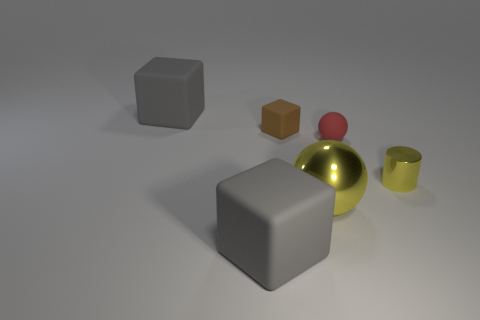What is the material of the large yellow ball?
Your answer should be compact. Metal. What number of metallic objects are tiny gray cylinders or large gray cubes?
Your answer should be very brief. 0. Is the number of small yellow cylinders that are left of the big yellow ball less than the number of gray rubber cubes that are in front of the small brown rubber cube?
Your answer should be very brief. Yes. There is a small yellow shiny cylinder that is behind the large gray matte thing that is in front of the yellow metal cylinder; is there a big gray matte thing that is in front of it?
Your answer should be compact. Yes. What is the material of the tiny cylinder that is the same color as the large metal object?
Your response must be concise. Metal. Does the yellow metal thing that is to the left of the red object have the same shape as the shiny object that is on the right side of the large yellow thing?
Provide a succinct answer. No. What is the material of the cylinder that is the same size as the brown cube?
Provide a short and direct response. Metal. Are the big thing behind the brown matte thing and the small object that is left of the tiny matte ball made of the same material?
Make the answer very short. Yes. The rubber object that is the same size as the red sphere is what shape?
Offer a terse response. Cube. What number of other things are there of the same color as the large shiny thing?
Your answer should be very brief. 1. 